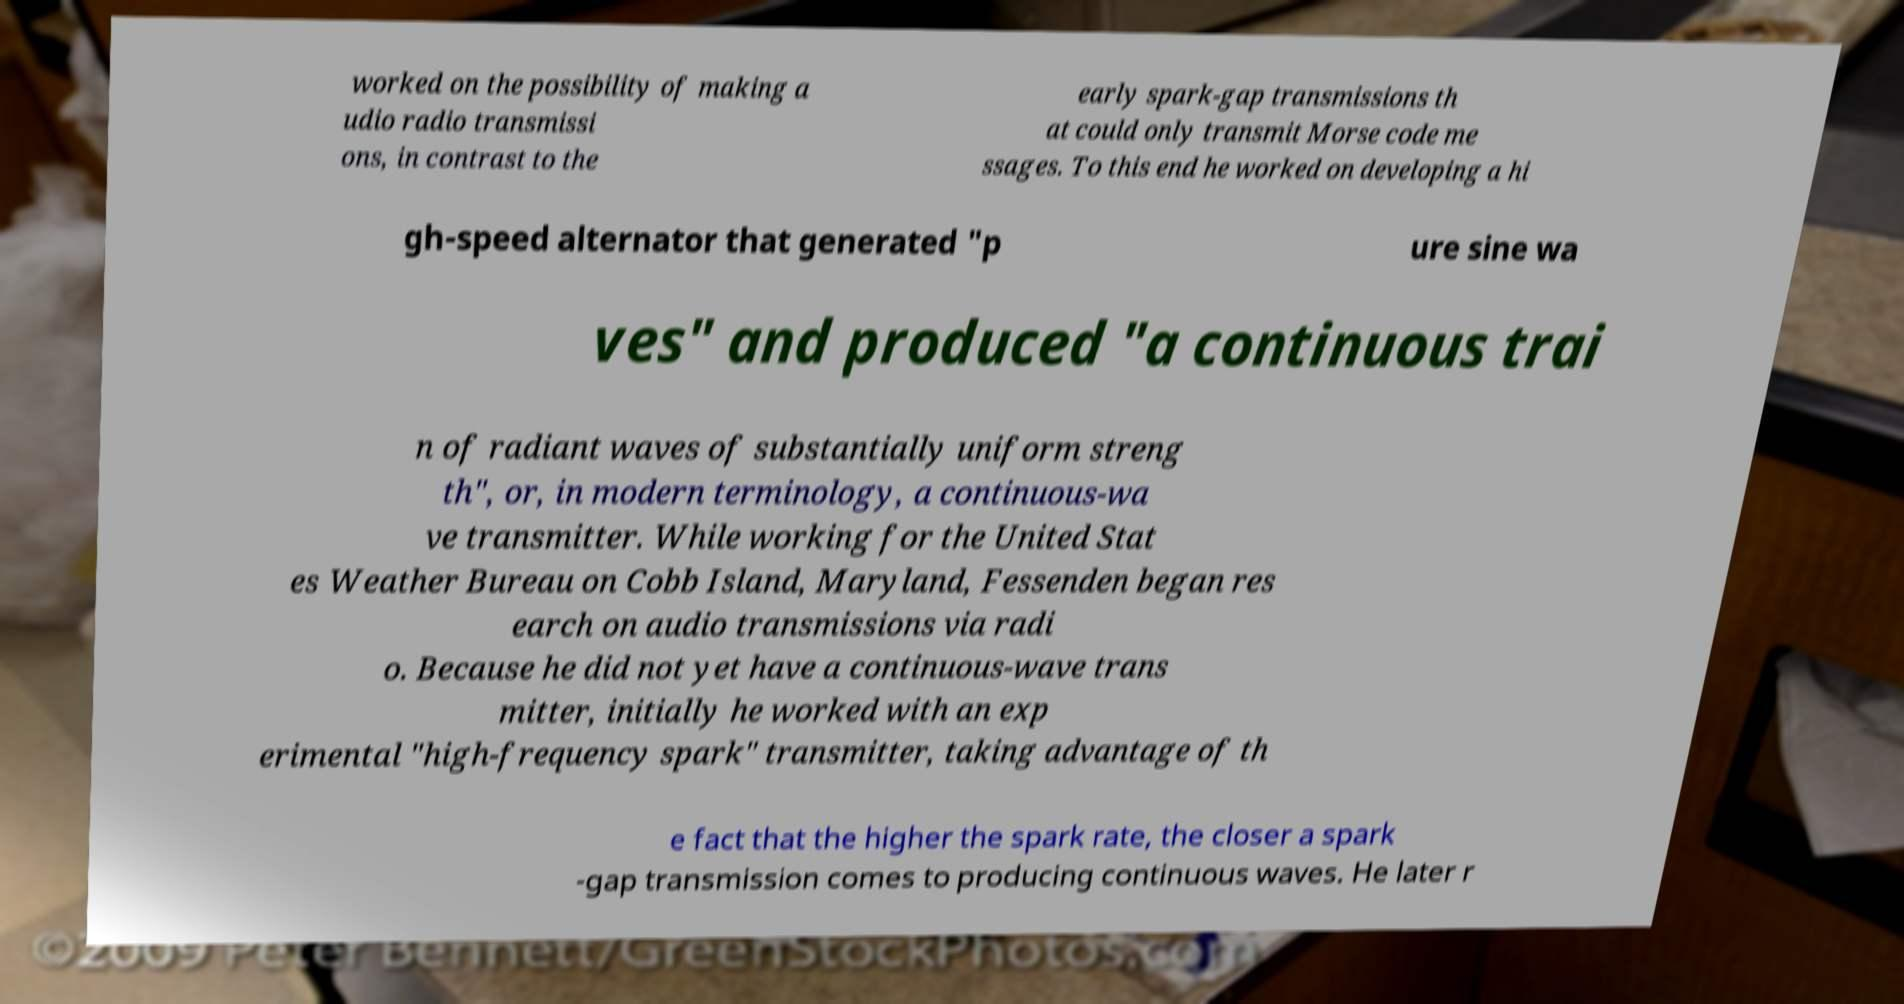Could you extract and type out the text from this image? worked on the possibility of making a udio radio transmissi ons, in contrast to the early spark-gap transmissions th at could only transmit Morse code me ssages. To this end he worked on developing a hi gh-speed alternator that generated "p ure sine wa ves" and produced "a continuous trai n of radiant waves of substantially uniform streng th", or, in modern terminology, a continuous-wa ve transmitter. While working for the United Stat es Weather Bureau on Cobb Island, Maryland, Fessenden began res earch on audio transmissions via radi o. Because he did not yet have a continuous-wave trans mitter, initially he worked with an exp erimental "high-frequency spark" transmitter, taking advantage of th e fact that the higher the spark rate, the closer a spark -gap transmission comes to producing continuous waves. He later r 